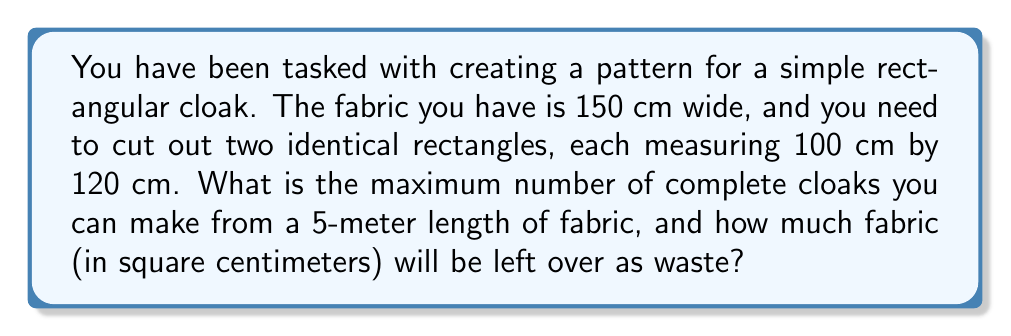Give your solution to this math problem. Let's approach this step-by-step:

1) First, we need to determine how many rectangles we can cut from the width of the fabric:
   
   Fabric width = 150 cm
   Rectangle width = 100 cm
   
   $$\lfloor 150 \div 100 \rfloor = 1$$
   
   This means we can only cut one rectangle across the width of the fabric.

2) Now, let's calculate how many rectangles we can cut along the length of the fabric:
   
   Fabric length = 500 cm (5 meters)
   Rectangle length = 120 cm
   
   $$\lfloor 500 \div 120 \rfloor = 4$$
   
   This means we can cut 4 rectangles along the length of the fabric.

3) Total number of rectangles we can cut:
   
   $$1 \times 4 = 4$$

4) Remember, we need 2 rectangles for each cloak. So the number of complete cloaks is:
   
   $$4 \div 2 = 2$$

5) Now, let's calculate the waste:
   - Total fabric area: $150 \times 500 = 75,000$ sq cm
   - Used fabric area: $4 \times (100 \times 120) = 48,000$ sq cm
   - Waste: $75,000 - 48,000 = 27,000$ sq cm

Therefore, we can make 2 complete cloaks with 27,000 sq cm of fabric left as waste.
Answer: 2 complete cloaks; 27,000 sq cm of waste 